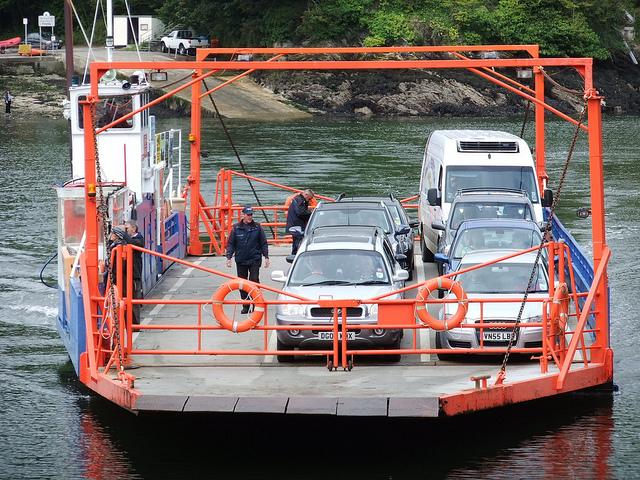Why are the vehicles on the boat? transport 